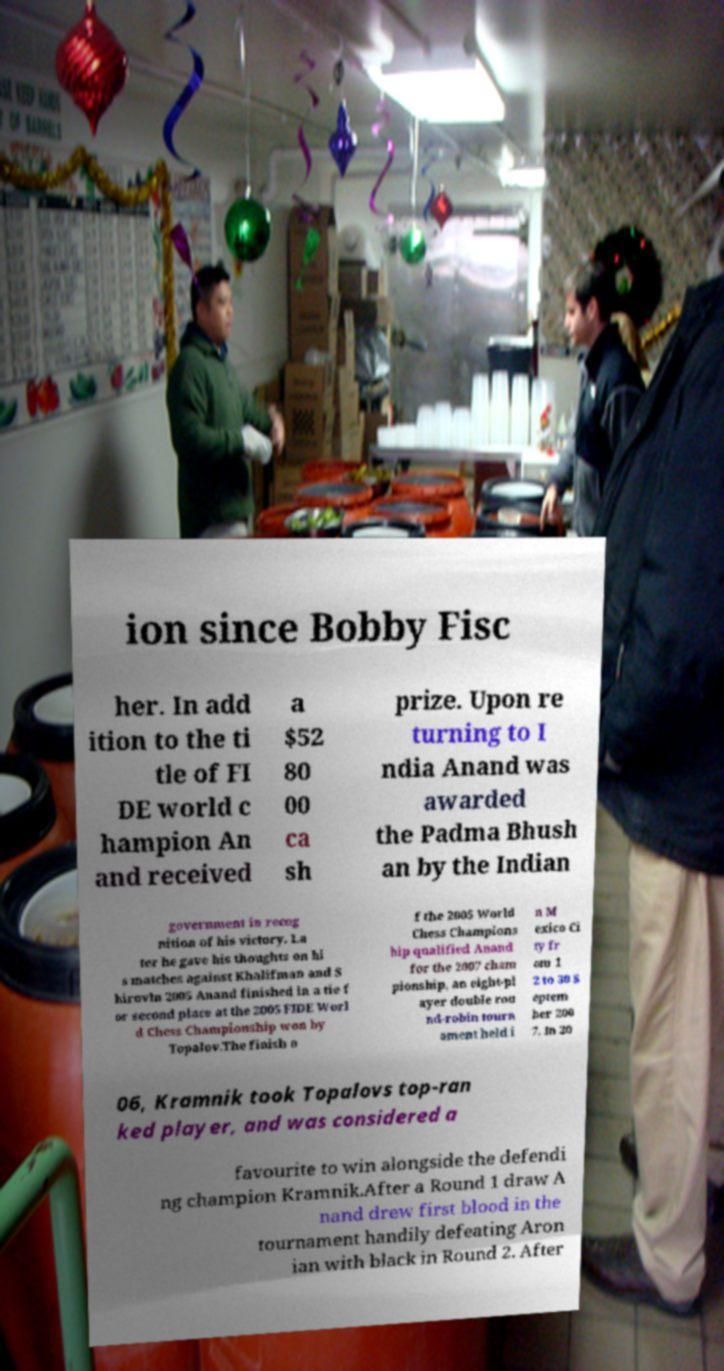What messages or text are displayed in this image? I need them in a readable, typed format. ion since Bobby Fisc her. In add ition to the ti tle of FI DE world c hampion An and received a $52 80 00 ca sh prize. Upon re turning to I ndia Anand was awarded the Padma Bhush an by the Indian government in recog nition of his victory. La ter he gave his thoughts on hi s matches against Khalifman and S hirovIn 2005 Anand finished in a tie f or second place at the 2005 FIDE Worl d Chess Championship won by Topalov.The finish o f the 2005 World Chess Champions hip qualified Anand for the 2007 cham pionship, an eight-pl ayer double rou nd-robin tourn ament held i n M exico Ci ty fr om 1 2 to 30 S eptem ber 200 7. In 20 06, Kramnik took Topalovs top-ran ked player, and was considered a favourite to win alongside the defendi ng champion Kramnik.After a Round 1 draw A nand drew first blood in the tournament handily defeating Aron ian with black in Round 2. After 